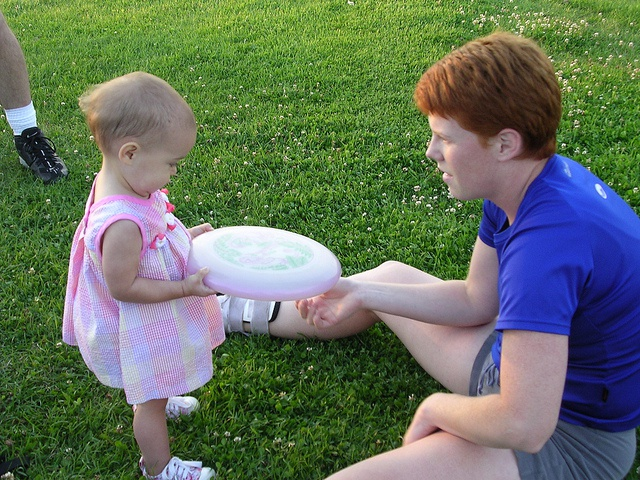Describe the objects in this image and their specific colors. I can see people in olive, darkgray, darkblue, navy, and gray tones, people in olive, darkgray, lavender, and gray tones, frisbee in olive, lavender, and darkgray tones, and people in olive, gray, black, and lightblue tones in this image. 